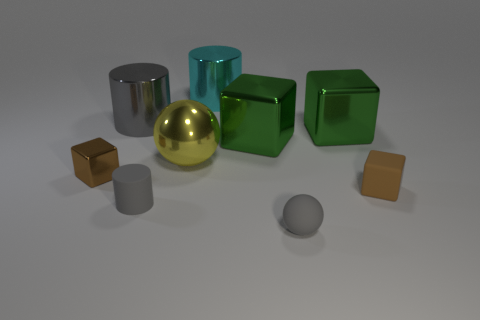Subtract all metal cubes. How many cubes are left? 1 Add 1 small red things. How many objects exist? 10 Subtract all purple cubes. Subtract all purple balls. How many cubes are left? 4 Subtract all cubes. How many objects are left? 5 Subtract 0 purple spheres. How many objects are left? 9 Subtract all green rubber cubes. Subtract all large metallic blocks. How many objects are left? 7 Add 7 big gray shiny cylinders. How many big gray shiny cylinders are left? 8 Add 5 large cyan rubber cubes. How many large cyan rubber cubes exist? 5 